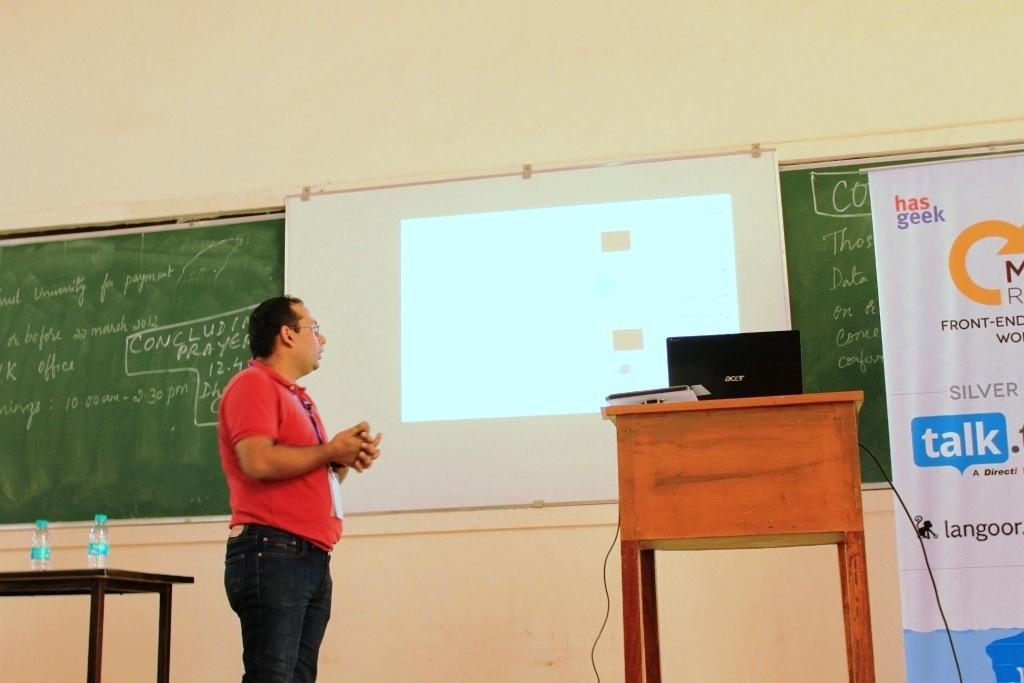In one or two sentences, can you explain what this image depicts? The person wearing red shirt is standing and looking at the projected image and there is a green board behind it and there is a table which has a laptop on it beside the person. 